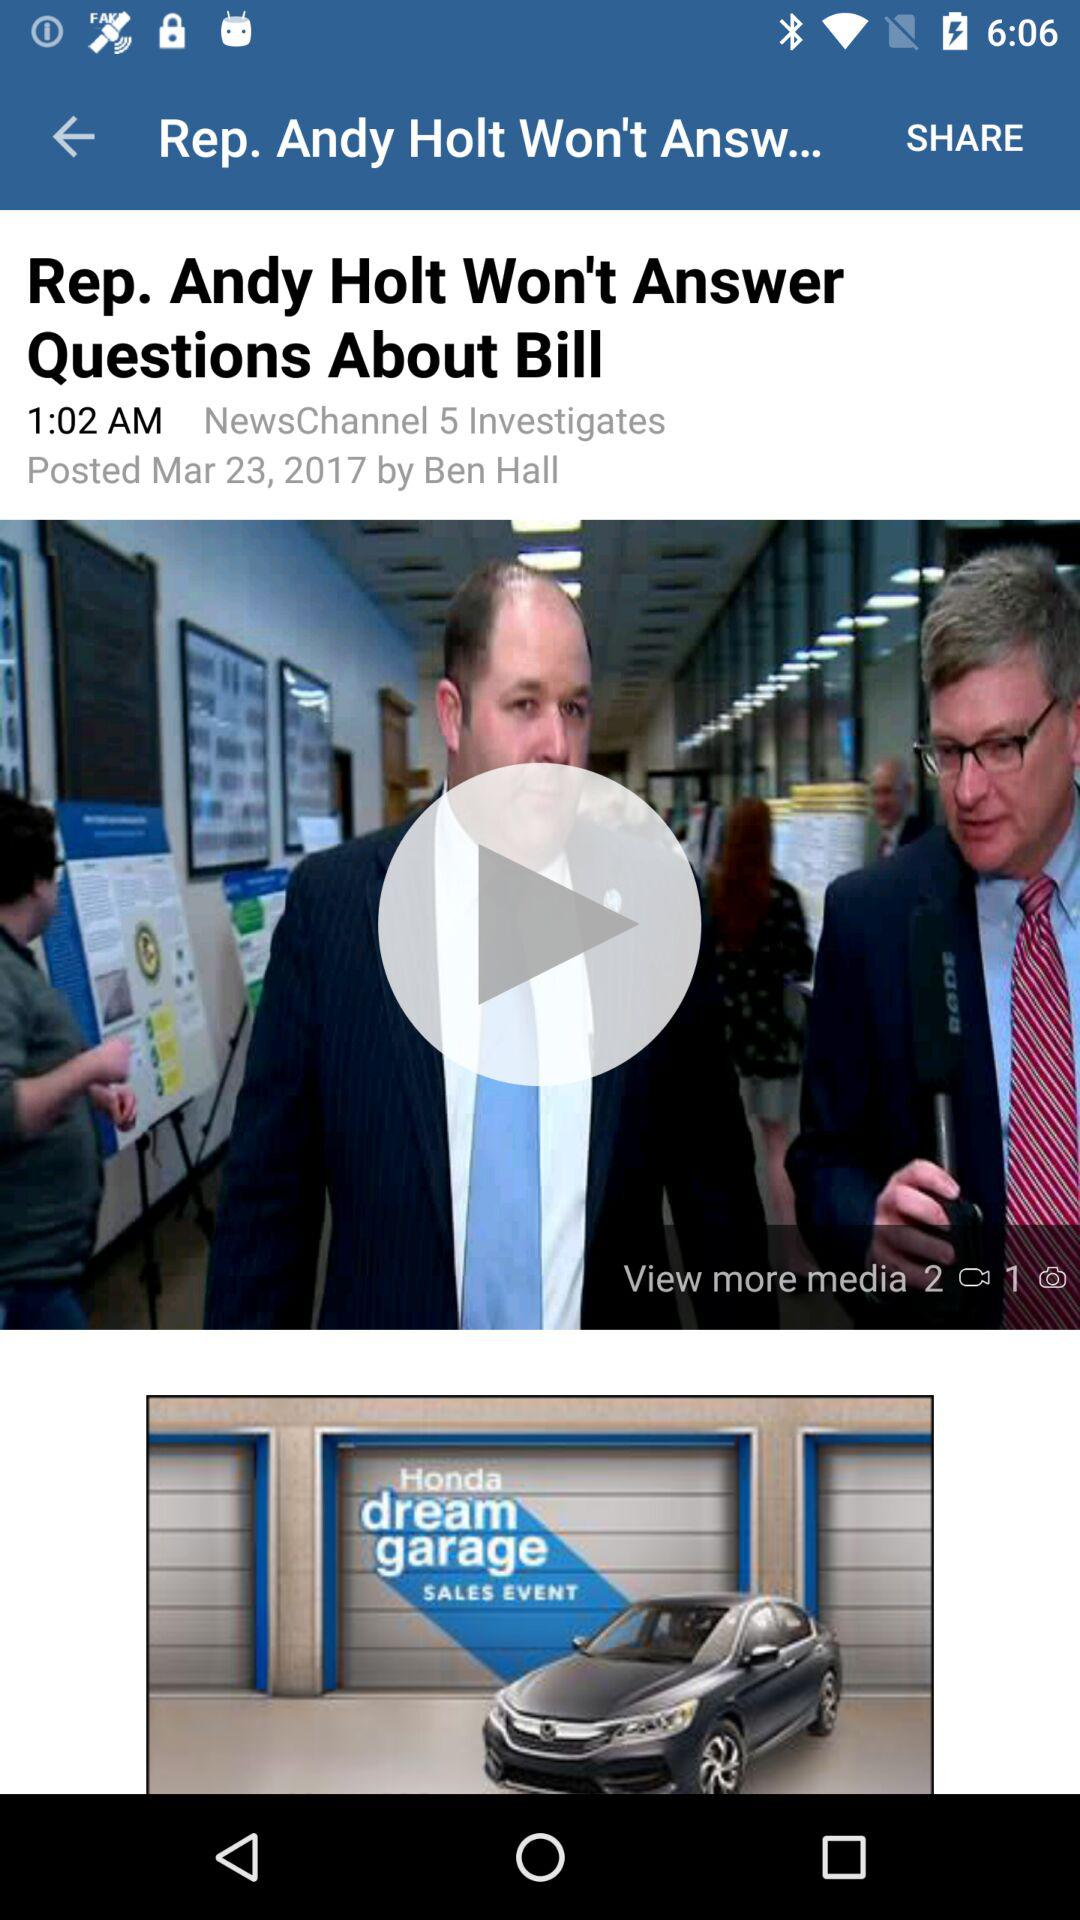What is the name of the author? The author's name is "Ben Hall". 